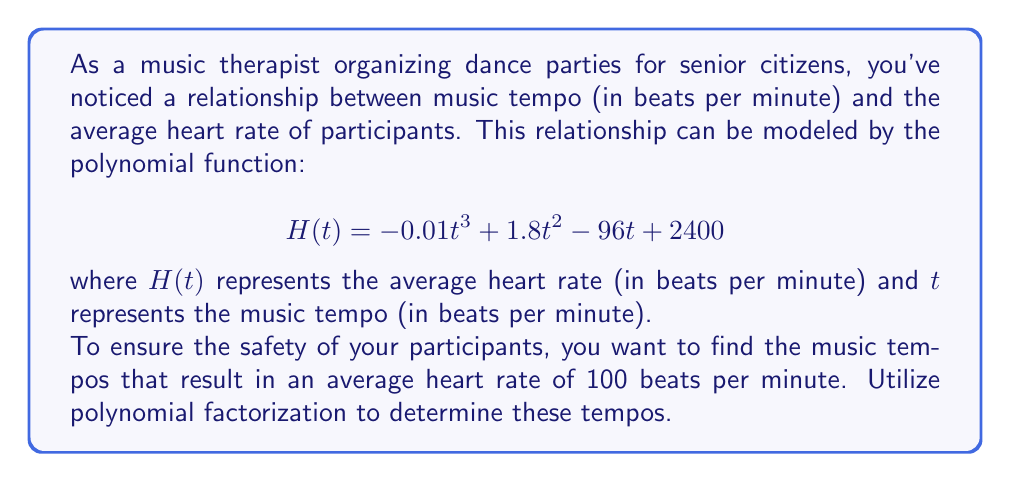Solve this math problem. To solve this problem, we need to follow these steps:

1) Set up the equation:
   $$H(t) = 100$$
   $$-0.01t^3 + 1.8t^2 - 96t + 2400 = 100$$

2) Rearrange the equation to standard form:
   $$-0.01t^3 + 1.8t^2 - 96t + 2300 = 0$$

3) Factor out the greatest common factor:
   $$-0.01(t^3 - 180t^2 + 9600t - 230000) = 0$$

4) Let $u = t - 60$ to simplify the equation:
   $$-0.01((u+60)^3 - 180(u+60)^2 + 9600(u+60) - 230000) = 0$$

5) Expand and simplify:
   $$-0.01(u^3 + 180u^2 + 10800u + 216000 - 180u^2 - 21600u - 648000 + 9600u + 576000 - 230000) = 0$$
   $$-0.01(u^3 - 1200u - 86000) = 0$$

6) Factor the cubic equation:
   $$-0.01(u - 100)(u^2 + 100u + 860) = 0$$

7) Solve for u:
   $u = 100$ (the quadratic factor has no real roots)

8) Substitute back $t = u + 60$:
   $t = 100 + 60 = 160$

Therefore, the only music tempo that results in an average heart rate of 100 beats per minute is 160 beats per minute.
Answer: 160 beats per minute 